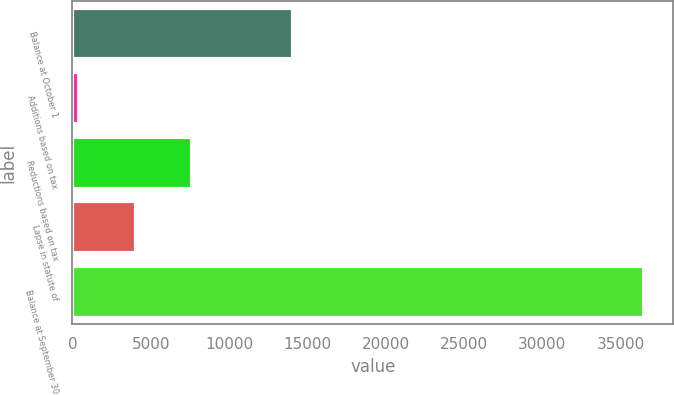<chart> <loc_0><loc_0><loc_500><loc_500><bar_chart><fcel>Balance at October 1<fcel>Additions based on tax<fcel>Reductions based on tax<fcel>Lapse in statute of<fcel>Balance at September 30<nl><fcel>14080<fcel>422<fcel>7639.4<fcel>4030.7<fcel>36509<nl></chart> 